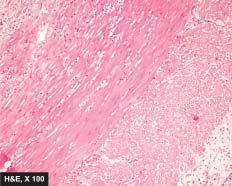re other changes present necrosis of mucosa and periappendicitis?
Answer the question using a single word or phrase. Yes 